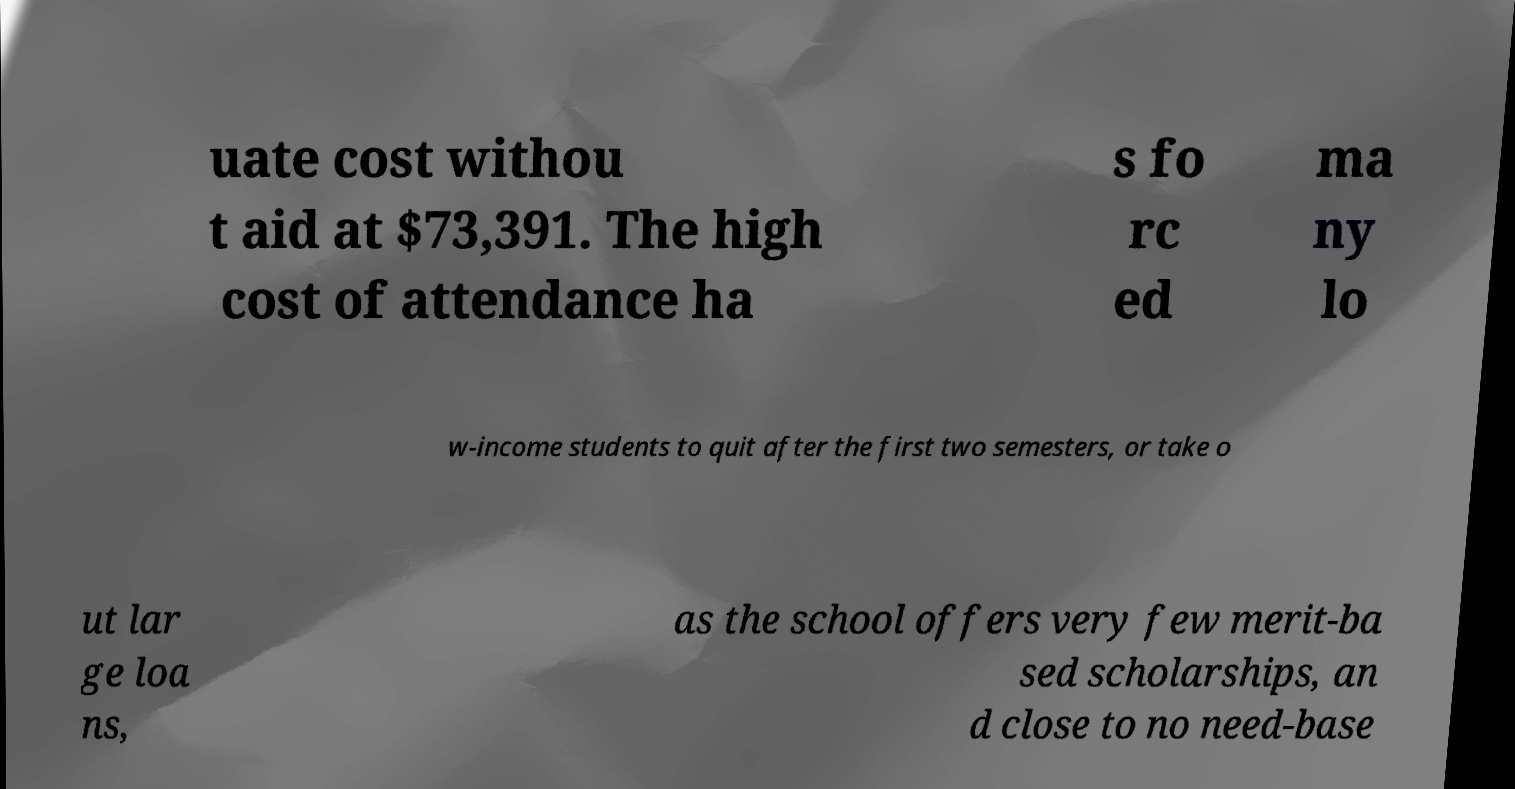For documentation purposes, I need the text within this image transcribed. Could you provide that? uate cost withou t aid at $73,391. The high cost of attendance ha s fo rc ed ma ny lo w-income students to quit after the first two semesters, or take o ut lar ge loa ns, as the school offers very few merit-ba sed scholarships, an d close to no need-base 